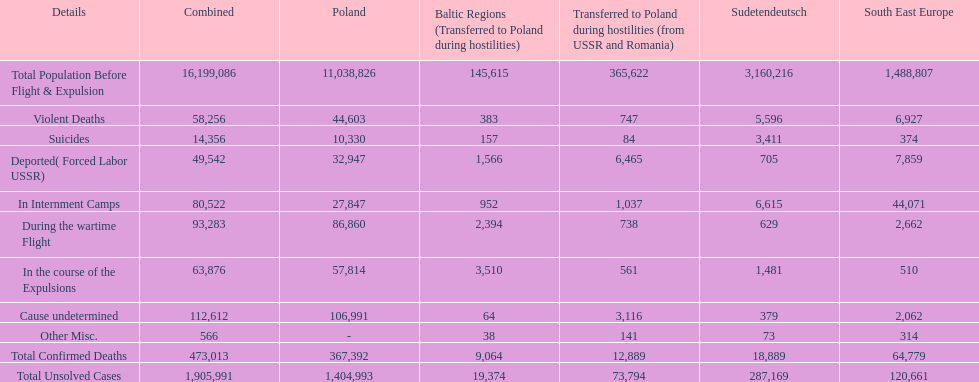Was there a larger total population before expulsion in poland or sudetendeutsch? Poland. 